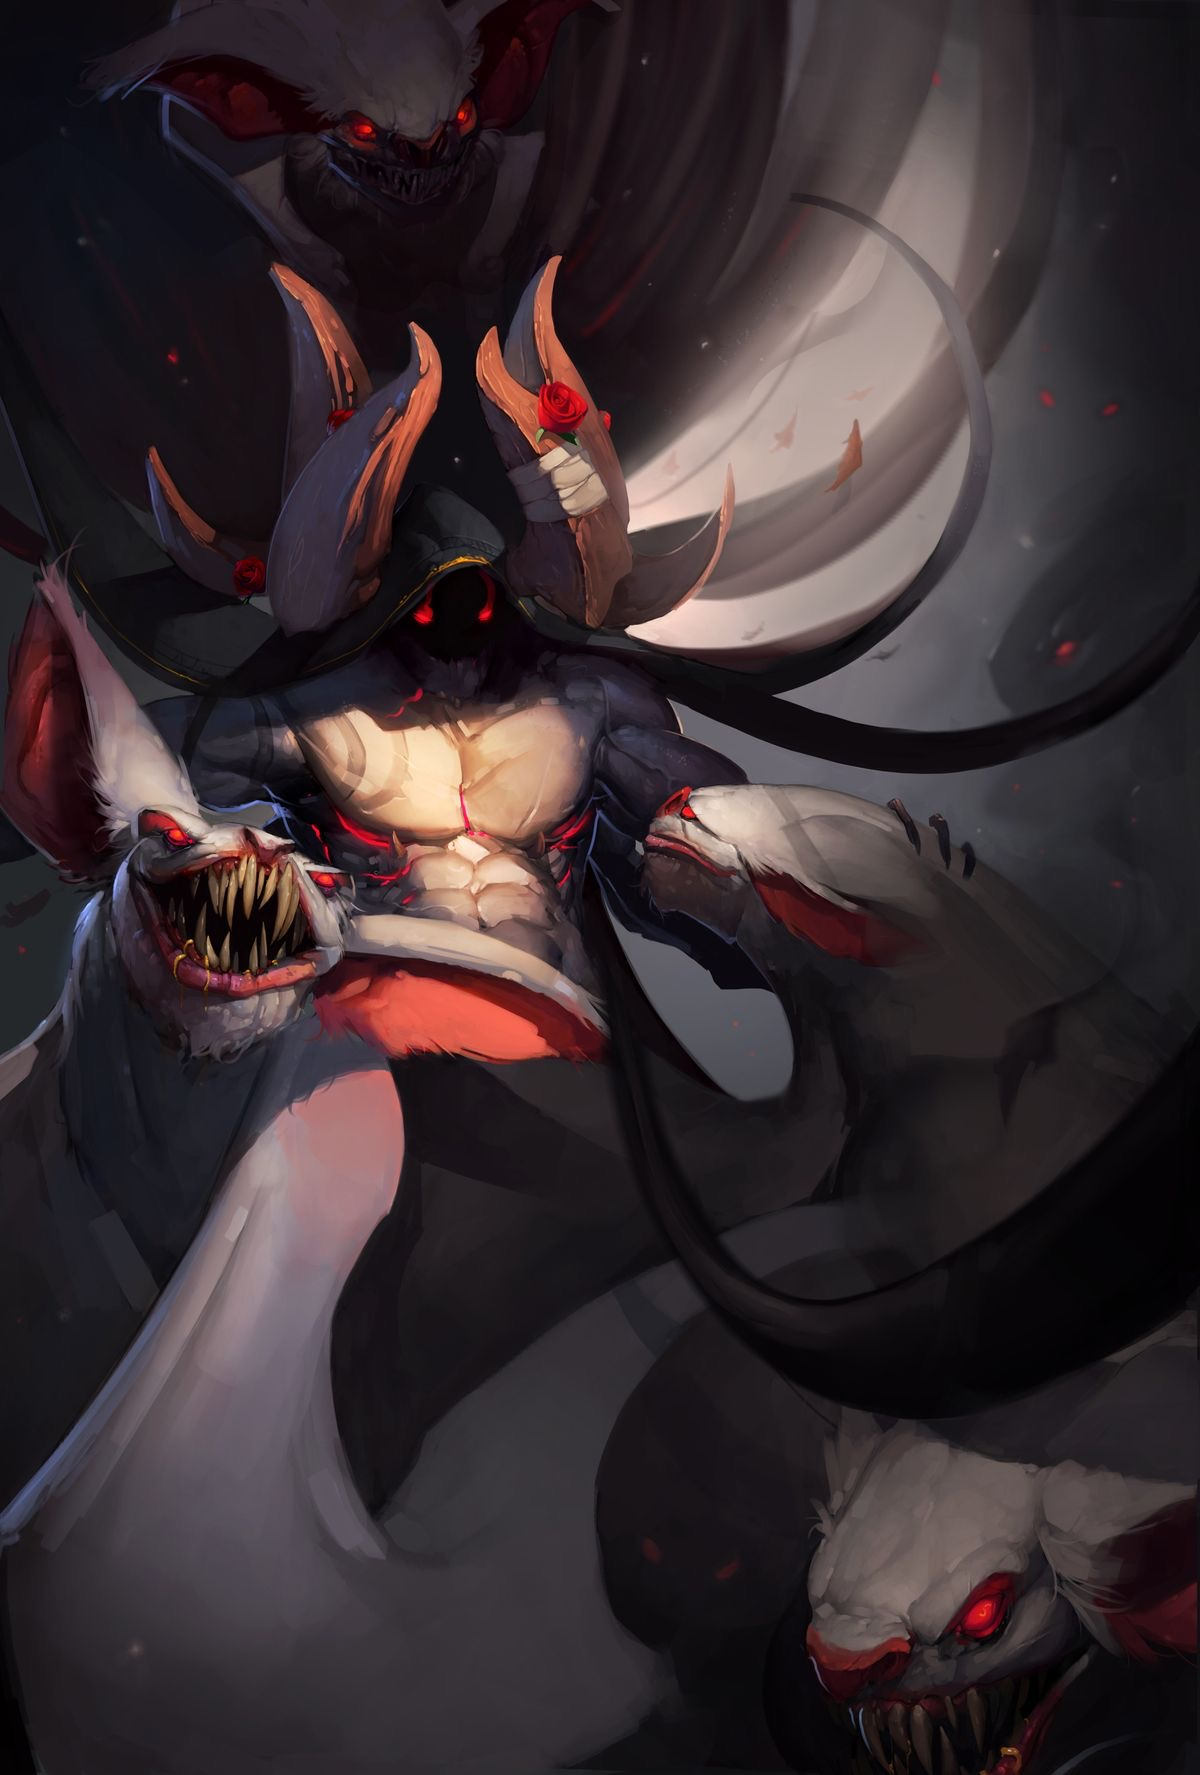describe this image in great detail, including details like the art style, medium, colors, and objects in the image. the word limit is 99  This digital artwork depicts a menacing, multi-headed creature in a dark, dynamic style. The central figure, with glowing red eyes and multiple fanged mouths, exudes a sinister aura. Each head has a distinct, grotesque expression, enhancing the sense of dread. The creature's skin transitions from deep gray to stark white, with vivid red accents at the eyes and mouths, suggesting a violent nature. The use of sharp, claw-like structures and swirling dark forms in the background adds to the chaotic atmosphere. The artwork masterfully employs a blend of smooth shading and harsh strokes, giving the creature a powerful, almost tangible presence. Roses, symbolically contrasting with the creature's ferocity, adorn its claws, adding a touch of elegance to the horror. 